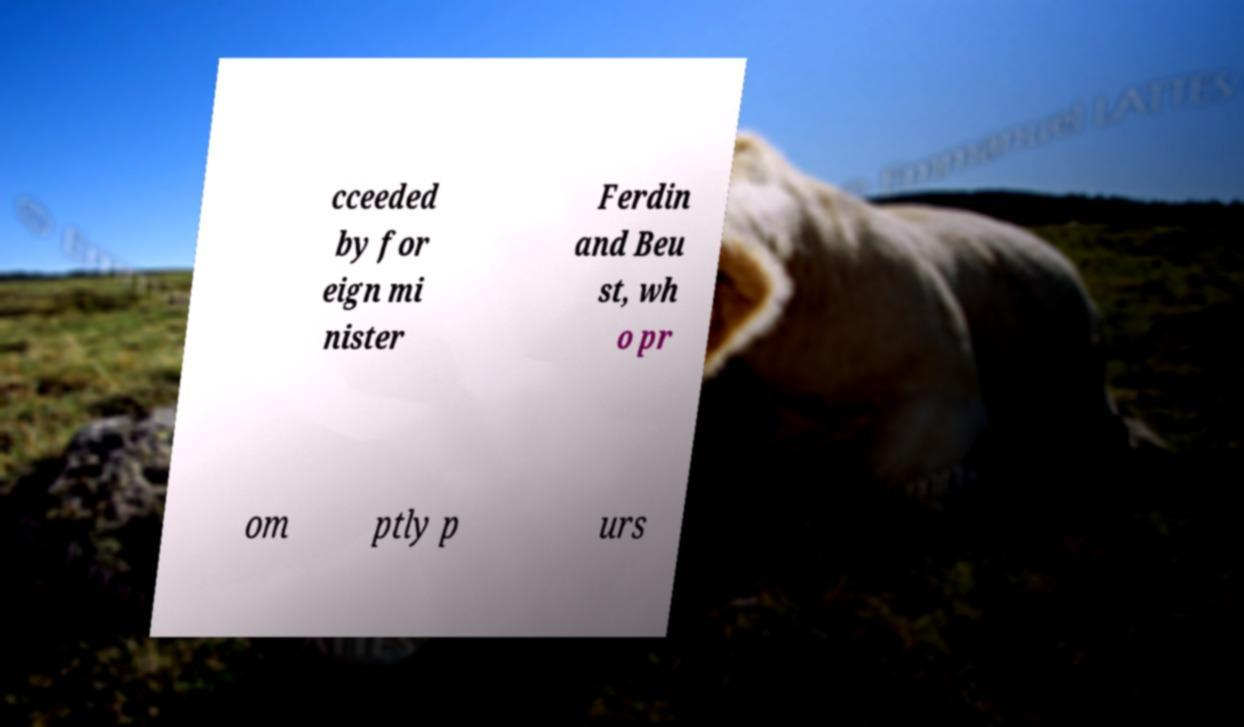There's text embedded in this image that I need extracted. Can you transcribe it verbatim? cceeded by for eign mi nister Ferdin and Beu st, wh o pr om ptly p urs 